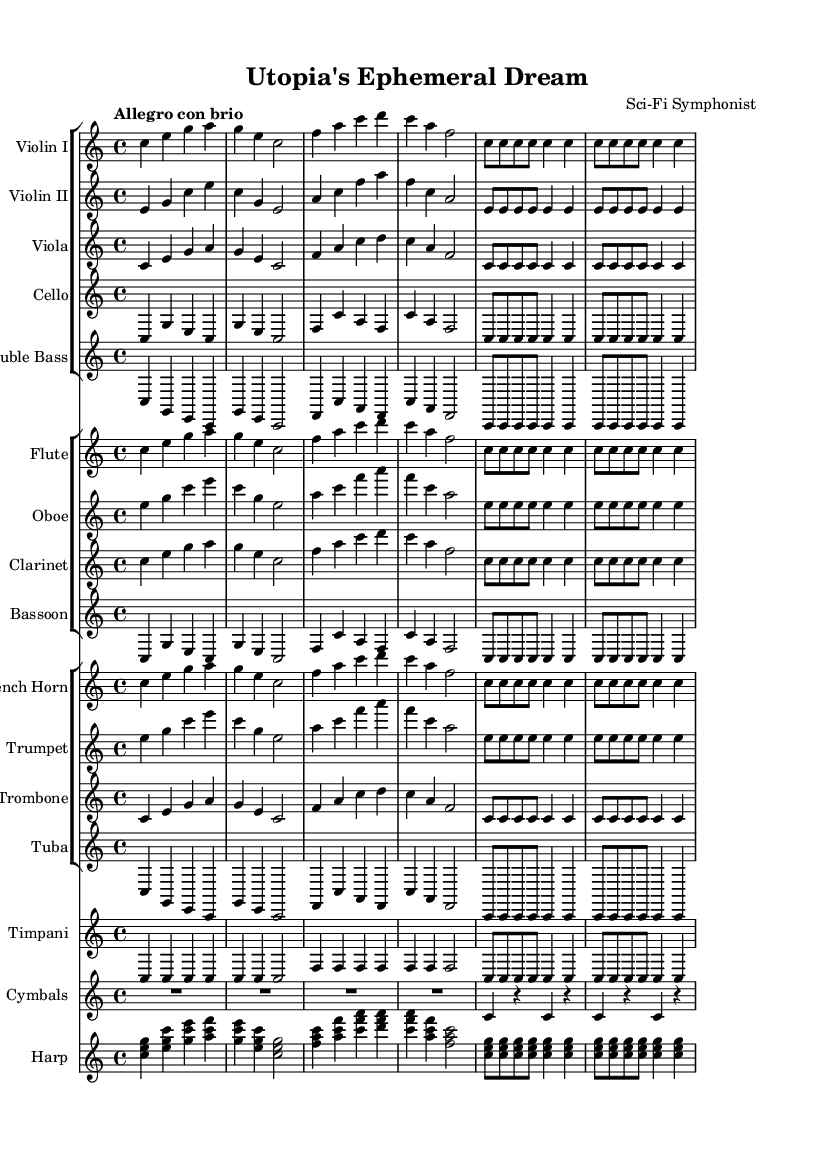What is the key signature of this music? The key signature is indicated at the beginning of the music and is C major, which has no sharps or flats.
Answer: C major What is the time signature of this music? The time signature is found at the beginning of the score, shown as 4/4, meaning four beats in a measure and a quarter note gets one beat.
Answer: 4/4 What is the tempo marking for this symphony? The tempo marking appears at the beginning of the score, where it states "Allegro con brio," indicating a fast and lively pace.
Answer: Allegro con brio How many instrument groups are there in this symphony? By examining the score layout, there are four distinct groups of instruments: strings, woodwinds, brass, and percussion, which are arranged in separate staff groups.
Answer: Four Which instrument plays the highest pitch in the first few measures? Analyzing the notes, the flute part starts with pitches that are higher compared to the other instruments, establishing it as the highest-pitched instrument in the initial measures.
Answer: Flute What motif is repeated by the strings throughout the symphony? The string sections show a specific rhythmic motif that is repeated in each instrument part, particularly in the first few measures, which consists of a series of quarter and eighth notes creating a recognizable theme.
Answer: Rhythmic motif of C, E, G What role does the timpani play in this symphony? The timpani adds depth and dynamic contrast, playing accentuated notes that bolster the underlying rhythm and marking significant beats within the symphonic structure, contributing to both tension and release in the piece.
Answer: Rhythmic accentuation 